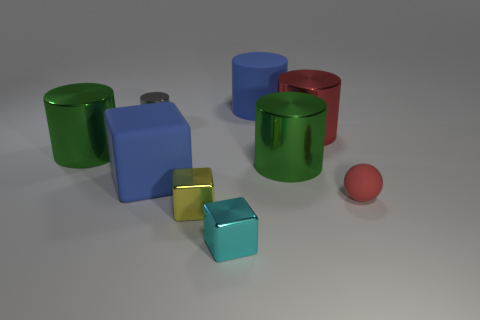What number of things are either tiny metallic balls or yellow metallic blocks that are in front of the tiny matte thing?
Give a very brief answer. 1. What is the color of the tiny cylinder that is made of the same material as the small cyan thing?
Give a very brief answer. Gray. How many big objects have the same material as the blue cylinder?
Your answer should be very brief. 1. How many yellow spheres are there?
Your answer should be compact. 0. Does the shiny object on the left side of the gray object have the same color as the big object behind the big red cylinder?
Your answer should be very brief. No. There is a tiny metal cylinder; what number of large objects are in front of it?
Offer a terse response. 4. There is a large block that is the same color as the large rubber cylinder; what is its material?
Offer a very short reply. Rubber. Is there a small gray metal object of the same shape as the tiny red matte object?
Give a very brief answer. No. Is the cube behind the tiny sphere made of the same material as the red object that is to the left of the tiny matte thing?
Offer a very short reply. No. There is a blue object in front of the small object left of the big block in front of the large red thing; how big is it?
Keep it short and to the point. Large. 